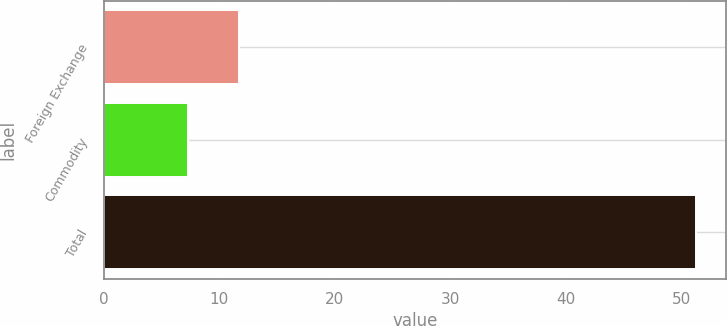Convert chart to OTSL. <chart><loc_0><loc_0><loc_500><loc_500><bar_chart><fcel>Foreign Exchange<fcel>Commodity<fcel>Total<nl><fcel>11.7<fcel>7.3<fcel>51.3<nl></chart> 